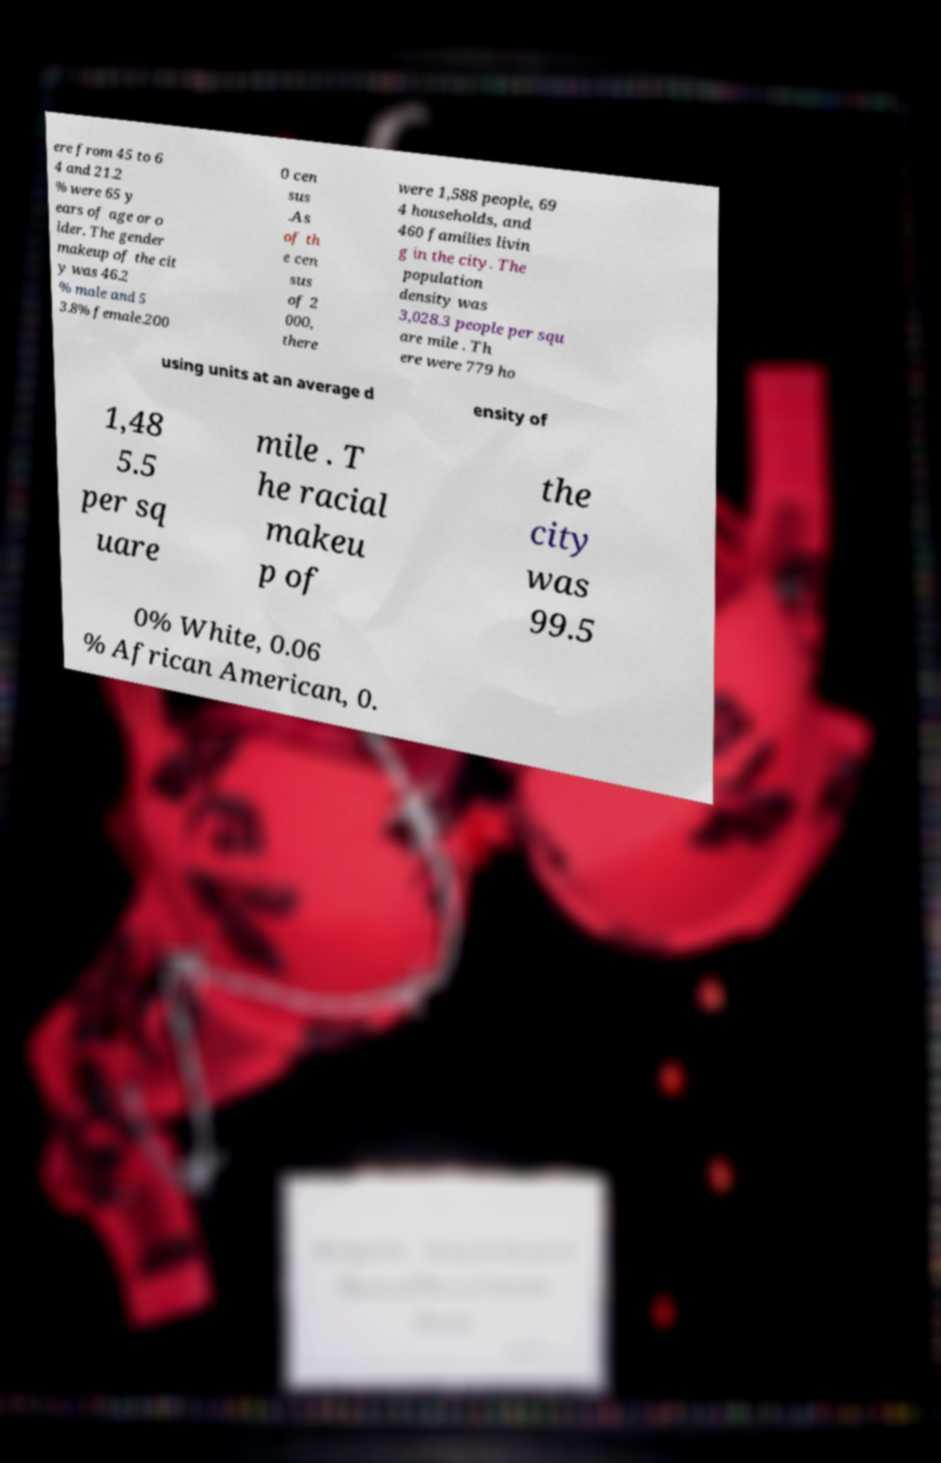Can you read and provide the text displayed in the image?This photo seems to have some interesting text. Can you extract and type it out for me? ere from 45 to 6 4 and 21.2 % were 65 y ears of age or o lder. The gender makeup of the cit y was 46.2 % male and 5 3.8% female.200 0 cen sus .As of th e cen sus of 2 000, there were 1,588 people, 69 4 households, and 460 families livin g in the city. The population density was 3,028.3 people per squ are mile . Th ere were 779 ho using units at an average d ensity of 1,48 5.5 per sq uare mile . T he racial makeu p of the city was 99.5 0% White, 0.06 % African American, 0. 